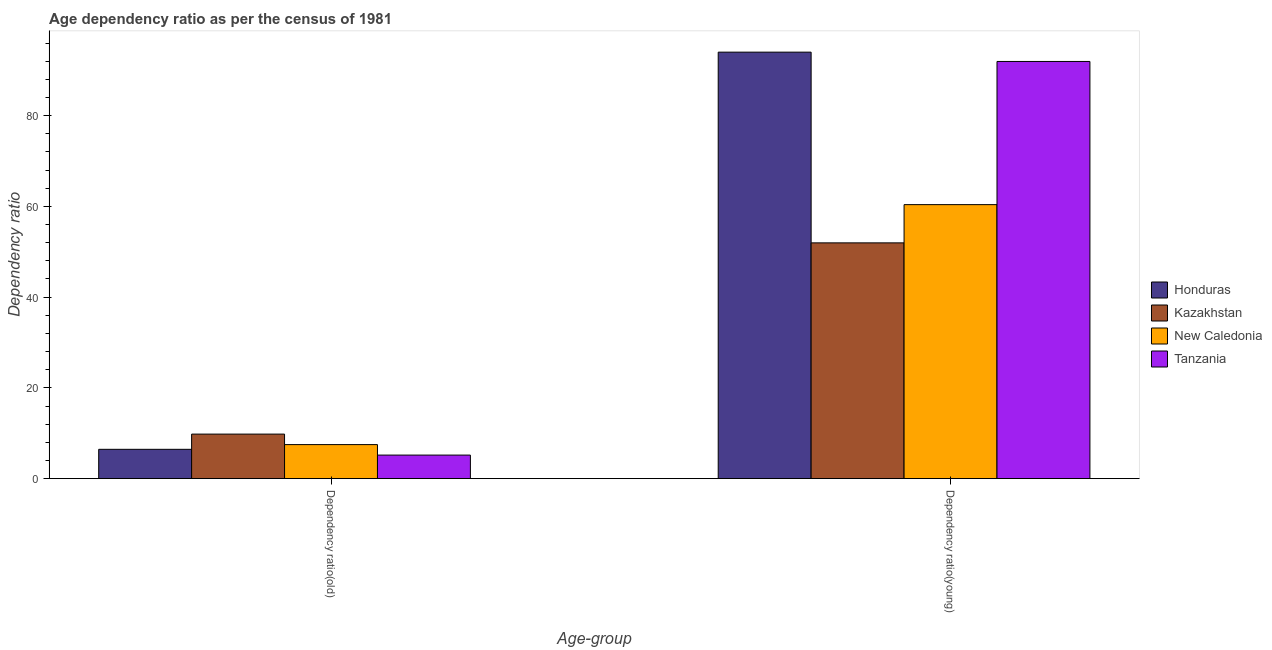How many different coloured bars are there?
Provide a short and direct response. 4. How many groups of bars are there?
Your response must be concise. 2. Are the number of bars on each tick of the X-axis equal?
Offer a terse response. Yes. How many bars are there on the 1st tick from the left?
Ensure brevity in your answer.  4. What is the label of the 2nd group of bars from the left?
Make the answer very short. Dependency ratio(young). What is the age dependency ratio(old) in New Caledonia?
Make the answer very short. 7.5. Across all countries, what is the maximum age dependency ratio(young)?
Offer a very short reply. 94. Across all countries, what is the minimum age dependency ratio(young)?
Give a very brief answer. 51.96. In which country was the age dependency ratio(old) maximum?
Keep it short and to the point. Kazakhstan. In which country was the age dependency ratio(old) minimum?
Ensure brevity in your answer.  Tanzania. What is the total age dependency ratio(old) in the graph?
Keep it short and to the point. 28.95. What is the difference between the age dependency ratio(old) in Kazakhstan and that in New Caledonia?
Your answer should be very brief. 2.32. What is the difference between the age dependency ratio(young) in Kazakhstan and the age dependency ratio(old) in Tanzania?
Your response must be concise. 46.78. What is the average age dependency ratio(old) per country?
Provide a succinct answer. 7.24. What is the difference between the age dependency ratio(old) and age dependency ratio(young) in Tanzania?
Give a very brief answer. -86.76. In how many countries, is the age dependency ratio(young) greater than 64 ?
Offer a very short reply. 2. What is the ratio of the age dependency ratio(old) in New Caledonia to that in Honduras?
Your answer should be very brief. 1.16. Is the age dependency ratio(young) in Honduras less than that in Tanzania?
Make the answer very short. No. In how many countries, is the age dependency ratio(old) greater than the average age dependency ratio(old) taken over all countries?
Ensure brevity in your answer.  2. What does the 4th bar from the left in Dependency ratio(old) represents?
Offer a terse response. Tanzania. What does the 1st bar from the right in Dependency ratio(young) represents?
Keep it short and to the point. Tanzania. How many bars are there?
Provide a short and direct response. 8. Are all the bars in the graph horizontal?
Keep it short and to the point. No. How many countries are there in the graph?
Keep it short and to the point. 4. What is the difference between two consecutive major ticks on the Y-axis?
Provide a short and direct response. 20. Does the graph contain any zero values?
Offer a very short reply. No. Does the graph contain grids?
Ensure brevity in your answer.  No. What is the title of the graph?
Ensure brevity in your answer.  Age dependency ratio as per the census of 1981. What is the label or title of the X-axis?
Provide a succinct answer. Age-group. What is the label or title of the Y-axis?
Make the answer very short. Dependency ratio. What is the Dependency ratio of Honduras in Dependency ratio(old)?
Offer a very short reply. 6.46. What is the Dependency ratio in Kazakhstan in Dependency ratio(old)?
Keep it short and to the point. 9.81. What is the Dependency ratio in New Caledonia in Dependency ratio(old)?
Give a very brief answer. 7.5. What is the Dependency ratio of Tanzania in Dependency ratio(old)?
Make the answer very short. 5.18. What is the Dependency ratio of Honduras in Dependency ratio(young)?
Offer a very short reply. 94. What is the Dependency ratio in Kazakhstan in Dependency ratio(young)?
Offer a very short reply. 51.96. What is the Dependency ratio of New Caledonia in Dependency ratio(young)?
Give a very brief answer. 60.39. What is the Dependency ratio of Tanzania in Dependency ratio(young)?
Provide a short and direct response. 91.95. Across all Age-group, what is the maximum Dependency ratio of Honduras?
Keep it short and to the point. 94. Across all Age-group, what is the maximum Dependency ratio in Kazakhstan?
Provide a succinct answer. 51.96. Across all Age-group, what is the maximum Dependency ratio of New Caledonia?
Provide a succinct answer. 60.39. Across all Age-group, what is the maximum Dependency ratio in Tanzania?
Make the answer very short. 91.95. Across all Age-group, what is the minimum Dependency ratio of Honduras?
Your response must be concise. 6.46. Across all Age-group, what is the minimum Dependency ratio of Kazakhstan?
Ensure brevity in your answer.  9.81. Across all Age-group, what is the minimum Dependency ratio of New Caledonia?
Make the answer very short. 7.5. Across all Age-group, what is the minimum Dependency ratio of Tanzania?
Offer a very short reply. 5.18. What is the total Dependency ratio in Honduras in the graph?
Keep it short and to the point. 100.46. What is the total Dependency ratio of Kazakhstan in the graph?
Offer a terse response. 61.77. What is the total Dependency ratio of New Caledonia in the graph?
Ensure brevity in your answer.  67.89. What is the total Dependency ratio in Tanzania in the graph?
Give a very brief answer. 97.13. What is the difference between the Dependency ratio of Honduras in Dependency ratio(old) and that in Dependency ratio(young)?
Make the answer very short. -87.54. What is the difference between the Dependency ratio of Kazakhstan in Dependency ratio(old) and that in Dependency ratio(young)?
Your response must be concise. -42.15. What is the difference between the Dependency ratio of New Caledonia in Dependency ratio(old) and that in Dependency ratio(young)?
Ensure brevity in your answer.  -52.89. What is the difference between the Dependency ratio in Tanzania in Dependency ratio(old) and that in Dependency ratio(young)?
Offer a terse response. -86.76. What is the difference between the Dependency ratio of Honduras in Dependency ratio(old) and the Dependency ratio of Kazakhstan in Dependency ratio(young)?
Your answer should be very brief. -45.51. What is the difference between the Dependency ratio in Honduras in Dependency ratio(old) and the Dependency ratio in New Caledonia in Dependency ratio(young)?
Keep it short and to the point. -53.93. What is the difference between the Dependency ratio of Honduras in Dependency ratio(old) and the Dependency ratio of Tanzania in Dependency ratio(young)?
Keep it short and to the point. -85.49. What is the difference between the Dependency ratio of Kazakhstan in Dependency ratio(old) and the Dependency ratio of New Caledonia in Dependency ratio(young)?
Keep it short and to the point. -50.58. What is the difference between the Dependency ratio of Kazakhstan in Dependency ratio(old) and the Dependency ratio of Tanzania in Dependency ratio(young)?
Keep it short and to the point. -82.14. What is the difference between the Dependency ratio in New Caledonia in Dependency ratio(old) and the Dependency ratio in Tanzania in Dependency ratio(young)?
Give a very brief answer. -84.45. What is the average Dependency ratio in Honduras per Age-group?
Keep it short and to the point. 50.23. What is the average Dependency ratio in Kazakhstan per Age-group?
Your answer should be very brief. 30.89. What is the average Dependency ratio of New Caledonia per Age-group?
Ensure brevity in your answer.  33.94. What is the average Dependency ratio of Tanzania per Age-group?
Your answer should be compact. 48.57. What is the difference between the Dependency ratio in Honduras and Dependency ratio in Kazakhstan in Dependency ratio(old)?
Provide a succinct answer. -3.35. What is the difference between the Dependency ratio in Honduras and Dependency ratio in New Caledonia in Dependency ratio(old)?
Offer a terse response. -1.04. What is the difference between the Dependency ratio of Honduras and Dependency ratio of Tanzania in Dependency ratio(old)?
Offer a very short reply. 1.27. What is the difference between the Dependency ratio in Kazakhstan and Dependency ratio in New Caledonia in Dependency ratio(old)?
Your response must be concise. 2.32. What is the difference between the Dependency ratio of Kazakhstan and Dependency ratio of Tanzania in Dependency ratio(old)?
Offer a very short reply. 4.63. What is the difference between the Dependency ratio in New Caledonia and Dependency ratio in Tanzania in Dependency ratio(old)?
Your answer should be compact. 2.31. What is the difference between the Dependency ratio in Honduras and Dependency ratio in Kazakhstan in Dependency ratio(young)?
Give a very brief answer. 42.04. What is the difference between the Dependency ratio of Honduras and Dependency ratio of New Caledonia in Dependency ratio(young)?
Provide a short and direct response. 33.61. What is the difference between the Dependency ratio in Honduras and Dependency ratio in Tanzania in Dependency ratio(young)?
Your answer should be compact. 2.05. What is the difference between the Dependency ratio of Kazakhstan and Dependency ratio of New Caledonia in Dependency ratio(young)?
Provide a short and direct response. -8.43. What is the difference between the Dependency ratio of Kazakhstan and Dependency ratio of Tanzania in Dependency ratio(young)?
Ensure brevity in your answer.  -39.98. What is the difference between the Dependency ratio of New Caledonia and Dependency ratio of Tanzania in Dependency ratio(young)?
Offer a terse response. -31.56. What is the ratio of the Dependency ratio of Honduras in Dependency ratio(old) to that in Dependency ratio(young)?
Give a very brief answer. 0.07. What is the ratio of the Dependency ratio of Kazakhstan in Dependency ratio(old) to that in Dependency ratio(young)?
Provide a short and direct response. 0.19. What is the ratio of the Dependency ratio of New Caledonia in Dependency ratio(old) to that in Dependency ratio(young)?
Your answer should be very brief. 0.12. What is the ratio of the Dependency ratio in Tanzania in Dependency ratio(old) to that in Dependency ratio(young)?
Offer a very short reply. 0.06. What is the difference between the highest and the second highest Dependency ratio of Honduras?
Keep it short and to the point. 87.54. What is the difference between the highest and the second highest Dependency ratio of Kazakhstan?
Your answer should be very brief. 42.15. What is the difference between the highest and the second highest Dependency ratio of New Caledonia?
Provide a succinct answer. 52.89. What is the difference between the highest and the second highest Dependency ratio of Tanzania?
Give a very brief answer. 86.76. What is the difference between the highest and the lowest Dependency ratio of Honduras?
Provide a short and direct response. 87.54. What is the difference between the highest and the lowest Dependency ratio in Kazakhstan?
Provide a short and direct response. 42.15. What is the difference between the highest and the lowest Dependency ratio of New Caledonia?
Offer a very short reply. 52.89. What is the difference between the highest and the lowest Dependency ratio in Tanzania?
Your answer should be very brief. 86.76. 